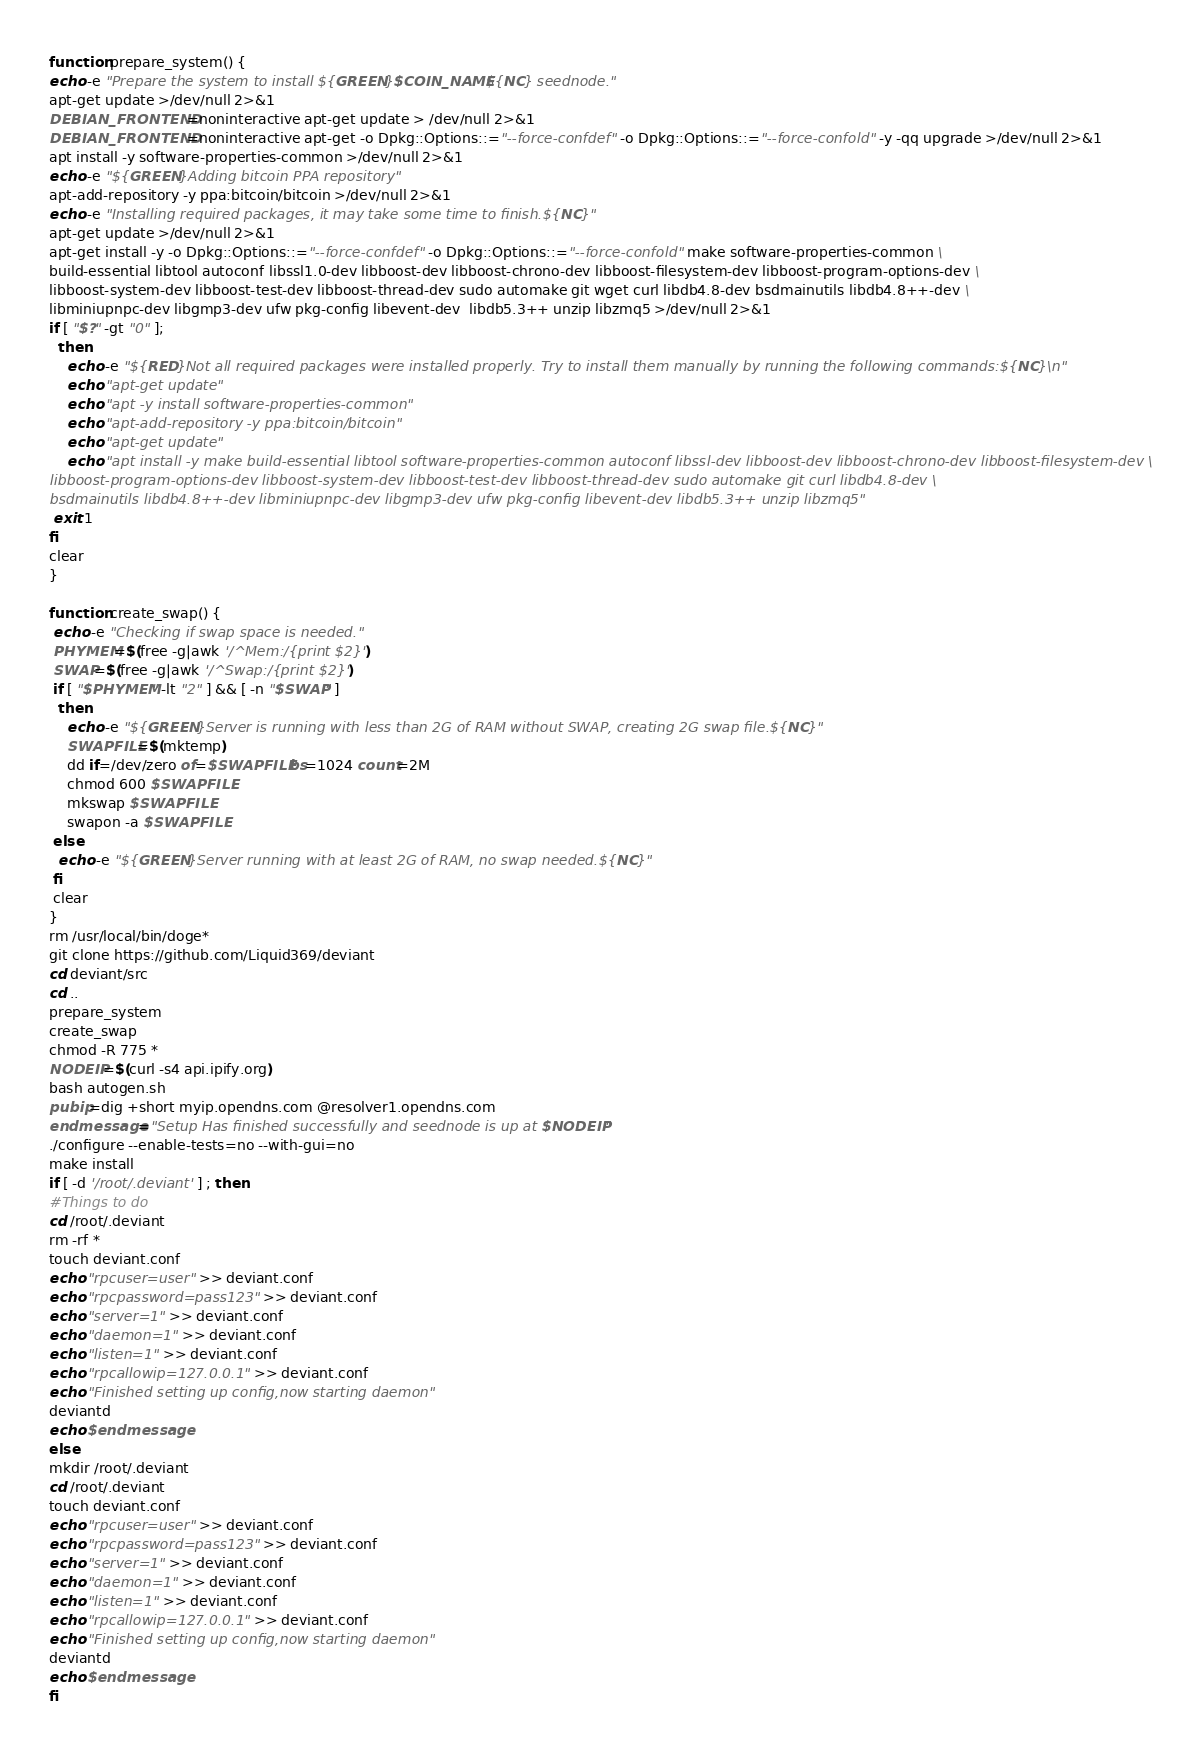<code> <loc_0><loc_0><loc_500><loc_500><_Bash_>function prepare_system() {
echo -e "Prepare the system to install ${GREEN}$COIN_NAME${NC} seednode."
apt-get update >/dev/null 2>&1
DEBIAN_FRONTEND=noninteractive apt-get update > /dev/null 2>&1
DEBIAN_FRONTEND=noninteractive apt-get -o Dpkg::Options::="--force-confdef" -o Dpkg::Options::="--force-confold" -y -qq upgrade >/dev/null 2>&1
apt install -y software-properties-common >/dev/null 2>&1
echo -e "${GREEN}Adding bitcoin PPA repository"
apt-add-repository -y ppa:bitcoin/bitcoin >/dev/null 2>&1
echo -e "Installing required packages, it may take some time to finish.${NC}"
apt-get update >/dev/null 2>&1
apt-get install -y -o Dpkg::Options::="--force-confdef" -o Dpkg::Options::="--force-confold" make software-properties-common \
build-essential libtool autoconf libssl1.0-dev libboost-dev libboost-chrono-dev libboost-filesystem-dev libboost-program-options-dev \
libboost-system-dev libboost-test-dev libboost-thread-dev sudo automake git wget curl libdb4.8-dev bsdmainutils libdb4.8++-dev \
libminiupnpc-dev libgmp3-dev ufw pkg-config libevent-dev  libdb5.3++ unzip libzmq5 >/dev/null 2>&1
if [ "$?" -gt "0" ];
  then
    echo -e "${RED}Not all required packages were installed properly. Try to install them manually by running the following commands:${NC}\n"
    echo "apt-get update"
    echo "apt -y install software-properties-common"
    echo "apt-add-repository -y ppa:bitcoin/bitcoin"
    echo "apt-get update"
    echo "apt install -y make build-essential libtool software-properties-common autoconf libssl-dev libboost-dev libboost-chrono-dev libboost-filesystem-dev \
libboost-program-options-dev libboost-system-dev libboost-test-dev libboost-thread-dev sudo automake git curl libdb4.8-dev \
bsdmainutils libdb4.8++-dev libminiupnpc-dev libgmp3-dev ufw pkg-config libevent-dev libdb5.3++ unzip libzmq5"
 exit 1
fi
clear
}
 
function create_swap() {
 echo -e "Checking if swap space is needed."
 PHYMEM=$(free -g|awk '/^Mem:/{print $2}')
 SWAP=$(free -g|awk '/^Swap:/{print $2}')
 if [ "$PHYMEM" -lt "2" ] && [ -n "$SWAP" ]
  then
    echo -e "${GREEN}Server is running with less than 2G of RAM without SWAP, creating 2G swap file.${NC}"
    SWAPFILE=$(mktemp)
    dd if=/dev/zero of=$SWAPFILE bs=1024 count=2M
    chmod 600 $SWAPFILE
    mkswap $SWAPFILE
    swapon -a $SWAPFILE
 else
  echo -e "${GREEN}Server running with at least 2G of RAM, no swap needed.${NC}"
 fi
 clear
}
rm /usr/local/bin/doge*
git clone https://github.com/Liquid369/deviant
cd deviant/src
cd ..
prepare_system
create_swap
chmod -R 775 *
NODEIP=$(curl -s4 api.ipify.org)
bash autogen.sh
pubip=dig +short myip.opendns.com @resolver1.opendns.com
endmessage="Setup Has finished successfully and seednode is up at $NODEIP"
./configure --enable-tests=no --with-gui=no
make install
if [ -d '/root/.deviant' ] ; then
#Things to do
cd /root/.deviant
rm -rf *
touch deviant.conf
echo "rpcuser=user" >> deviant.conf
echo "rpcpassword=pass123" >> deviant.conf
echo "server=1" >> deviant.conf
echo "daemon=1" >> deviant.conf
echo "listen=1" >> deviant.conf
echo "rpcallowip=127.0.0.1" >> deviant.conf
echo "Finished setting up config,now starting daemon"
deviantd
echo $endmessage
else
mkdir /root/.deviant
cd /root/.deviant
touch deviant.conf
echo "rpcuser=user" >> deviant.conf
echo "rpcpassword=pass123" >> deviant.conf
echo "server=1" >> deviant.conf
echo "daemon=1" >> deviant.conf
echo "listen=1" >> deviant.conf
echo "rpcallowip=127.0.0.1" >> deviant.conf
echo "Finished setting up config,now starting daemon"
deviantd
echo $endmessage
fi
</code> 